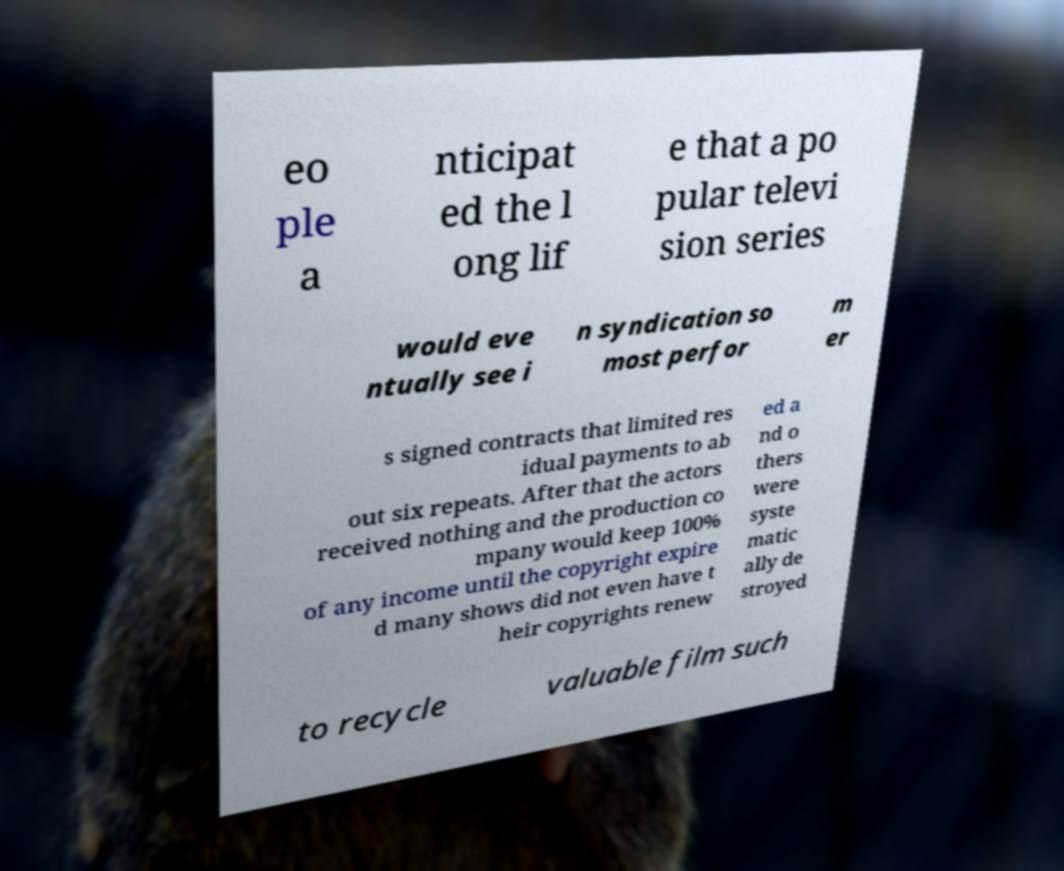For documentation purposes, I need the text within this image transcribed. Could you provide that? eo ple a nticipat ed the l ong lif e that a po pular televi sion series would eve ntually see i n syndication so most perfor m er s signed contracts that limited res idual payments to ab out six repeats. After that the actors received nothing and the production co mpany would keep 100% of any income until the copyright expire d many shows did not even have t heir copyrights renew ed a nd o thers were syste matic ally de stroyed to recycle valuable film such 